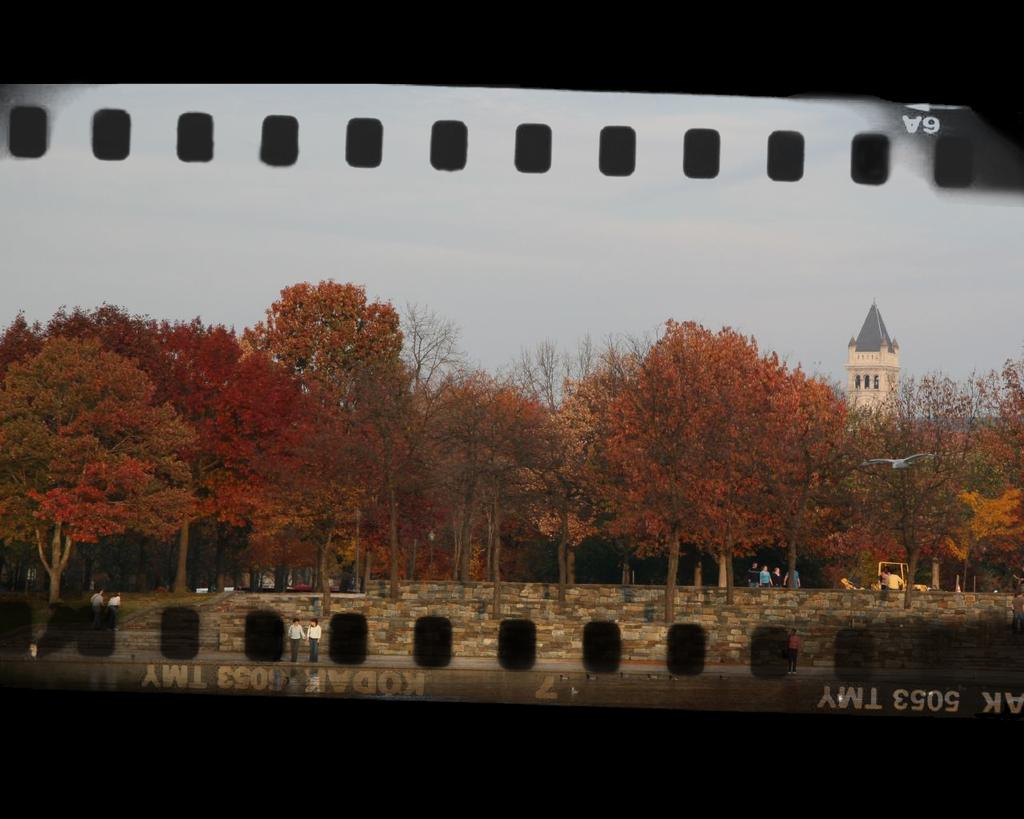<image>
Render a clear and concise summary of the photo. A strip of film negative has the code 5053 TMY on it. 